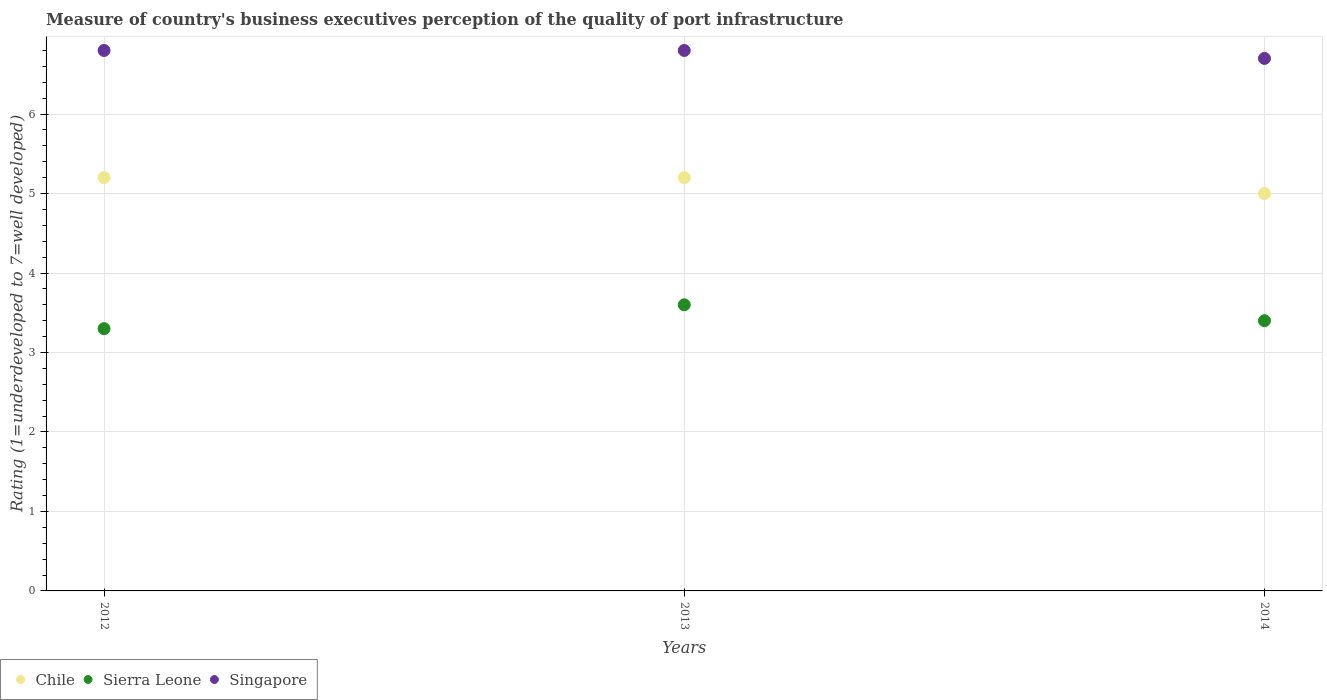Is the number of dotlines equal to the number of legend labels?
Offer a terse response. Yes. Across all years, what is the maximum ratings of the quality of port infrastructure in Chile?
Ensure brevity in your answer.  5.2. Across all years, what is the minimum ratings of the quality of port infrastructure in Chile?
Your answer should be very brief. 5. What is the total ratings of the quality of port infrastructure in Chile in the graph?
Give a very brief answer. 15.4. What is the difference between the ratings of the quality of port infrastructure in Chile in 2013 and the ratings of the quality of port infrastructure in Singapore in 2014?
Your answer should be compact. -1.5. What is the average ratings of the quality of port infrastructure in Singapore per year?
Your response must be concise. 6.77. In the year 2012, what is the difference between the ratings of the quality of port infrastructure in Sierra Leone and ratings of the quality of port infrastructure in Singapore?
Your answer should be very brief. -3.5. In how many years, is the ratings of the quality of port infrastructure in Sierra Leone greater than 2.2?
Your answer should be very brief. 3. What is the ratio of the ratings of the quality of port infrastructure in Singapore in 2013 to that in 2014?
Offer a very short reply. 1.01. What is the difference between the highest and the second highest ratings of the quality of port infrastructure in Sierra Leone?
Your answer should be compact. 0.2. What is the difference between the highest and the lowest ratings of the quality of port infrastructure in Singapore?
Offer a terse response. 0.1. In how many years, is the ratings of the quality of port infrastructure in Singapore greater than the average ratings of the quality of port infrastructure in Singapore taken over all years?
Provide a succinct answer. 2. Does the ratings of the quality of port infrastructure in Singapore monotonically increase over the years?
Provide a short and direct response. No. Is the ratings of the quality of port infrastructure in Singapore strictly less than the ratings of the quality of port infrastructure in Sierra Leone over the years?
Provide a short and direct response. No. How many years are there in the graph?
Keep it short and to the point. 3. What is the difference between two consecutive major ticks on the Y-axis?
Ensure brevity in your answer.  1. Are the values on the major ticks of Y-axis written in scientific E-notation?
Ensure brevity in your answer.  No. Does the graph contain any zero values?
Ensure brevity in your answer.  No. How are the legend labels stacked?
Make the answer very short. Horizontal. What is the title of the graph?
Give a very brief answer. Measure of country's business executives perception of the quality of port infrastructure. Does "Guinea-Bissau" appear as one of the legend labels in the graph?
Your answer should be very brief. No. What is the label or title of the X-axis?
Offer a very short reply. Years. What is the label or title of the Y-axis?
Your response must be concise. Rating (1=underdeveloped to 7=well developed). What is the Rating (1=underdeveloped to 7=well developed) in Chile in 2012?
Give a very brief answer. 5.2. What is the Rating (1=underdeveloped to 7=well developed) of Chile in 2013?
Offer a very short reply. 5.2. What is the Rating (1=underdeveloped to 7=well developed) of Sierra Leone in 2013?
Offer a very short reply. 3.6. What is the Rating (1=underdeveloped to 7=well developed) of Chile in 2014?
Give a very brief answer. 5. What is the Rating (1=underdeveloped to 7=well developed) in Singapore in 2014?
Offer a very short reply. 6.7. Across all years, what is the minimum Rating (1=underdeveloped to 7=well developed) in Sierra Leone?
Provide a short and direct response. 3.3. Across all years, what is the minimum Rating (1=underdeveloped to 7=well developed) of Singapore?
Provide a succinct answer. 6.7. What is the total Rating (1=underdeveloped to 7=well developed) in Singapore in the graph?
Ensure brevity in your answer.  20.3. What is the difference between the Rating (1=underdeveloped to 7=well developed) in Chile in 2012 and that in 2013?
Your answer should be compact. 0. What is the difference between the Rating (1=underdeveloped to 7=well developed) of Singapore in 2012 and that in 2013?
Make the answer very short. 0. What is the difference between the Rating (1=underdeveloped to 7=well developed) in Sierra Leone in 2013 and that in 2014?
Your answer should be very brief. 0.2. What is the difference between the Rating (1=underdeveloped to 7=well developed) in Singapore in 2013 and that in 2014?
Give a very brief answer. 0.1. What is the difference between the Rating (1=underdeveloped to 7=well developed) in Chile in 2012 and the Rating (1=underdeveloped to 7=well developed) in Sierra Leone in 2014?
Make the answer very short. 1.8. What is the difference between the Rating (1=underdeveloped to 7=well developed) in Chile in 2013 and the Rating (1=underdeveloped to 7=well developed) in Sierra Leone in 2014?
Make the answer very short. 1.8. What is the difference between the Rating (1=underdeveloped to 7=well developed) in Chile in 2013 and the Rating (1=underdeveloped to 7=well developed) in Singapore in 2014?
Ensure brevity in your answer.  -1.5. What is the difference between the Rating (1=underdeveloped to 7=well developed) in Sierra Leone in 2013 and the Rating (1=underdeveloped to 7=well developed) in Singapore in 2014?
Keep it short and to the point. -3.1. What is the average Rating (1=underdeveloped to 7=well developed) of Chile per year?
Offer a terse response. 5.13. What is the average Rating (1=underdeveloped to 7=well developed) in Sierra Leone per year?
Make the answer very short. 3.43. What is the average Rating (1=underdeveloped to 7=well developed) of Singapore per year?
Give a very brief answer. 6.77. In the year 2012, what is the difference between the Rating (1=underdeveloped to 7=well developed) of Chile and Rating (1=underdeveloped to 7=well developed) of Sierra Leone?
Make the answer very short. 1.9. In the year 2012, what is the difference between the Rating (1=underdeveloped to 7=well developed) of Sierra Leone and Rating (1=underdeveloped to 7=well developed) of Singapore?
Make the answer very short. -3.5. In the year 2013, what is the difference between the Rating (1=underdeveloped to 7=well developed) of Chile and Rating (1=underdeveloped to 7=well developed) of Sierra Leone?
Your response must be concise. 1.6. In the year 2013, what is the difference between the Rating (1=underdeveloped to 7=well developed) of Chile and Rating (1=underdeveloped to 7=well developed) of Singapore?
Give a very brief answer. -1.6. In the year 2013, what is the difference between the Rating (1=underdeveloped to 7=well developed) in Sierra Leone and Rating (1=underdeveloped to 7=well developed) in Singapore?
Make the answer very short. -3.2. In the year 2014, what is the difference between the Rating (1=underdeveloped to 7=well developed) in Chile and Rating (1=underdeveloped to 7=well developed) in Sierra Leone?
Offer a very short reply. 1.6. What is the ratio of the Rating (1=underdeveloped to 7=well developed) in Chile in 2012 to that in 2013?
Your answer should be compact. 1. What is the ratio of the Rating (1=underdeveloped to 7=well developed) of Sierra Leone in 2012 to that in 2013?
Your response must be concise. 0.92. What is the ratio of the Rating (1=underdeveloped to 7=well developed) in Sierra Leone in 2012 to that in 2014?
Keep it short and to the point. 0.97. What is the ratio of the Rating (1=underdeveloped to 7=well developed) of Singapore in 2012 to that in 2014?
Make the answer very short. 1.01. What is the ratio of the Rating (1=underdeveloped to 7=well developed) in Chile in 2013 to that in 2014?
Your response must be concise. 1.04. What is the ratio of the Rating (1=underdeveloped to 7=well developed) of Sierra Leone in 2013 to that in 2014?
Your answer should be very brief. 1.06. What is the ratio of the Rating (1=underdeveloped to 7=well developed) of Singapore in 2013 to that in 2014?
Offer a very short reply. 1.01. What is the difference between the highest and the second highest Rating (1=underdeveloped to 7=well developed) in Sierra Leone?
Provide a succinct answer. 0.2. What is the difference between the highest and the second highest Rating (1=underdeveloped to 7=well developed) of Singapore?
Offer a terse response. 0. What is the difference between the highest and the lowest Rating (1=underdeveloped to 7=well developed) of Sierra Leone?
Offer a terse response. 0.3. 